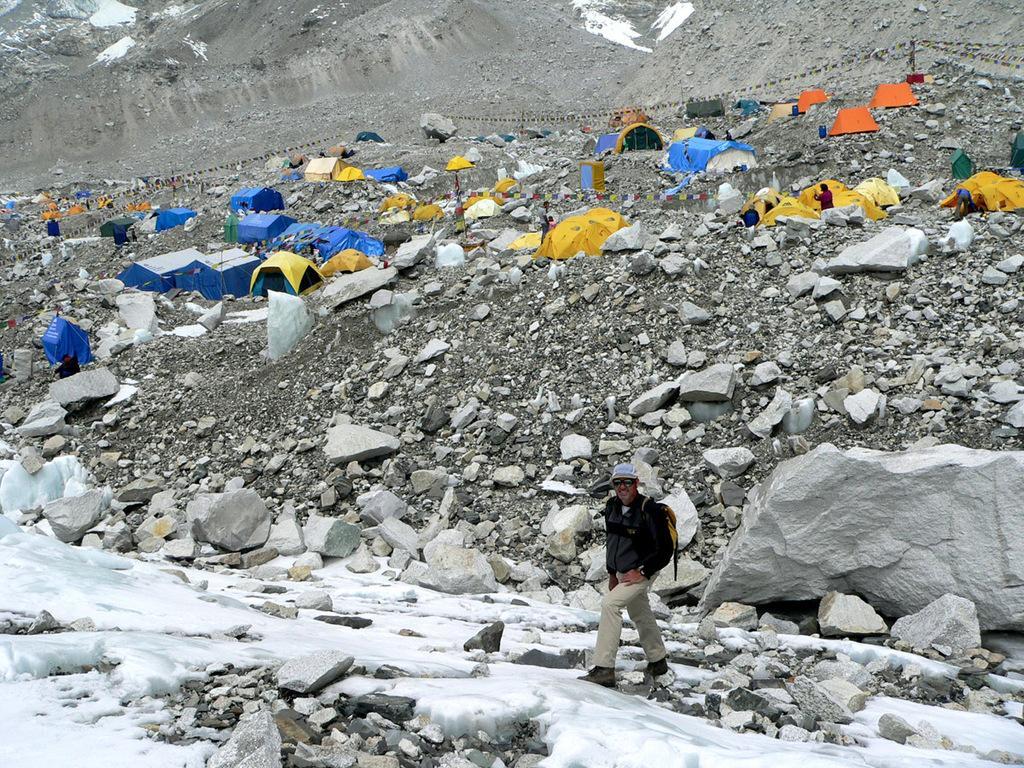Describe this image in one or two sentences. This picture shows a man walking and he wore a cap on his head and sunglasses on his face and a backpack on is back and we see tents and rocks and few people standing. 